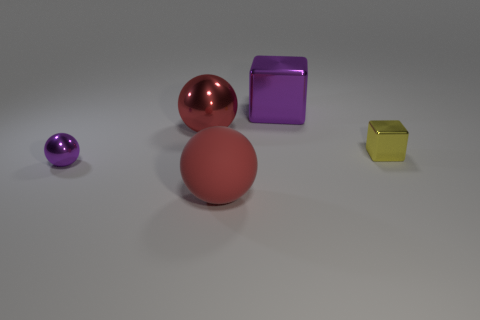What number of objects are behind the small ball and in front of the big red shiny object? 1 